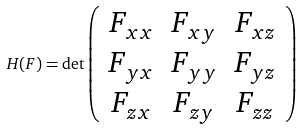<formula> <loc_0><loc_0><loc_500><loc_500>H ( F ) = \det \left ( \begin{array} { c c c } F _ { x x } & F _ { x y } & F _ { x z } \\ F _ { y x } & F _ { y y } & F _ { y z } \\ F _ { z x } & F _ { z y } & F _ { z z } \end{array} \right )</formula> 